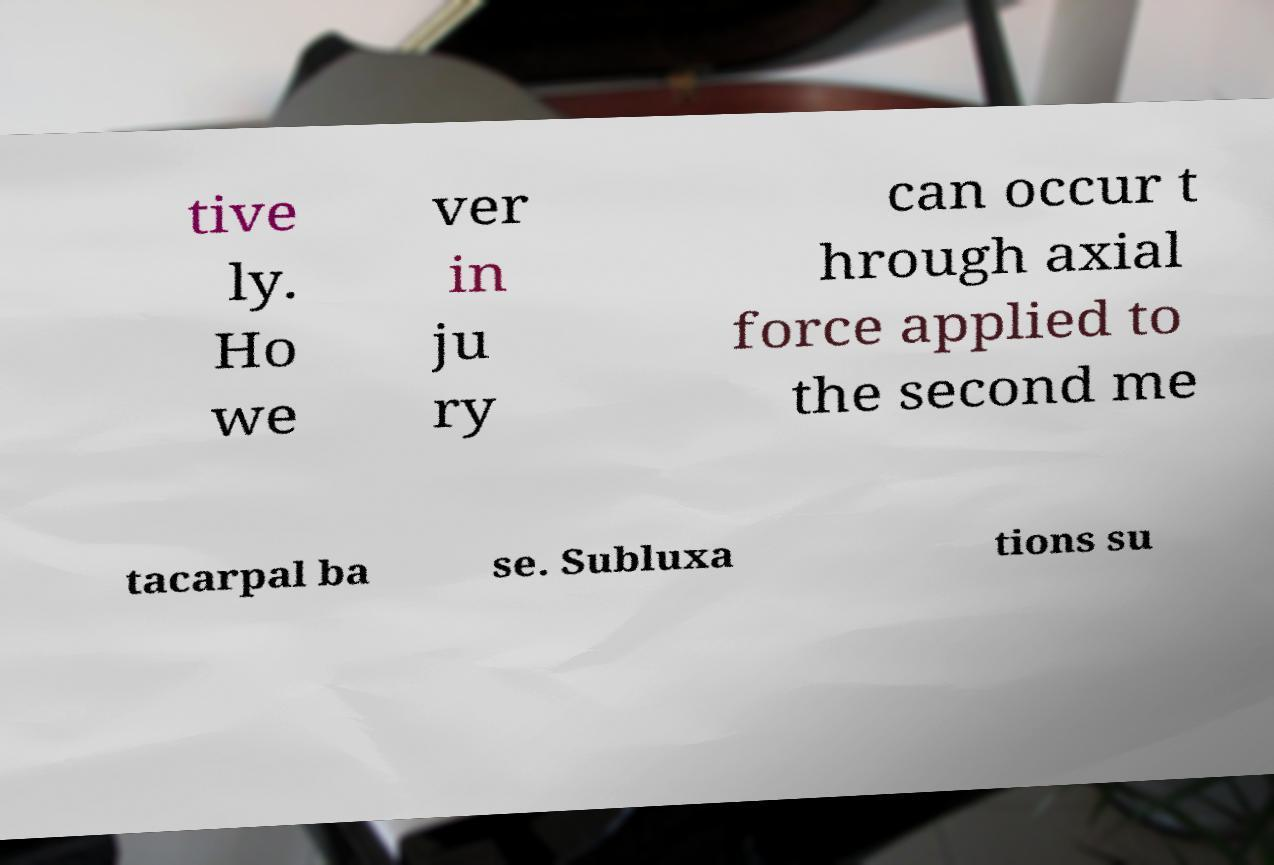Please read and relay the text visible in this image. What does it say? tive ly. Ho we ver in ju ry can occur t hrough axial force applied to the second me tacarpal ba se. Subluxa tions su 